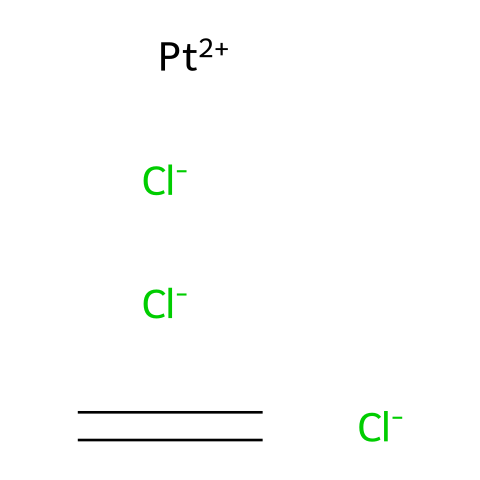What is the coordination number of platinum in Zeise's salt? The platinum atom in Zeise's salt is coordinated to two chloride ions and one alkene (ethene) molecule. This results in a total of three coordination sites occupied by ligands.
Answer: three How many chlorine atoms are present in Zeise's salt? By examining the SMILES representation, there are two instances of [Cl-], indicating that there are two chlorine atoms present.
Answer: two What is the oxidation state of platinum in this compound? The platinum is represented as [Pt+2], indicating it has a +2 oxidation state. This is derived from the positive charge associated with the platinum in the complex.
Answer: +2 Which type of compound is Zeise's salt primarily classified as? Zeise's salt is classified as an organometallic compound because it contains a metal (platinum) and a carbon-containing alkene (ethene) in its structure.
Answer: organometallic What type of bonding is primarily present between platinum and the alkene? The bonding between platinum and the ethene molecule involves coordinate covalent bonding, where the alkene donates a pair of electrons to form a bond with the platinum.
Answer: coordinate covalent How many total atoms are in the Zeise's salt molecule? To compute the total atoms, we count two chlorine atoms, one platinum atom, and four carbon and hydrogen atoms from the ethene (C2H4) component: 2 (Cl) + 1 (Pt) + 4 (C & H) = 7 total atoms.
Answer: seven What is the functional group present in the ethene part of Zeise's salt? The ethene contains a double bond (C=C), which is the defining feature of alkenes and serves as its functional group.
Answer: double bond 